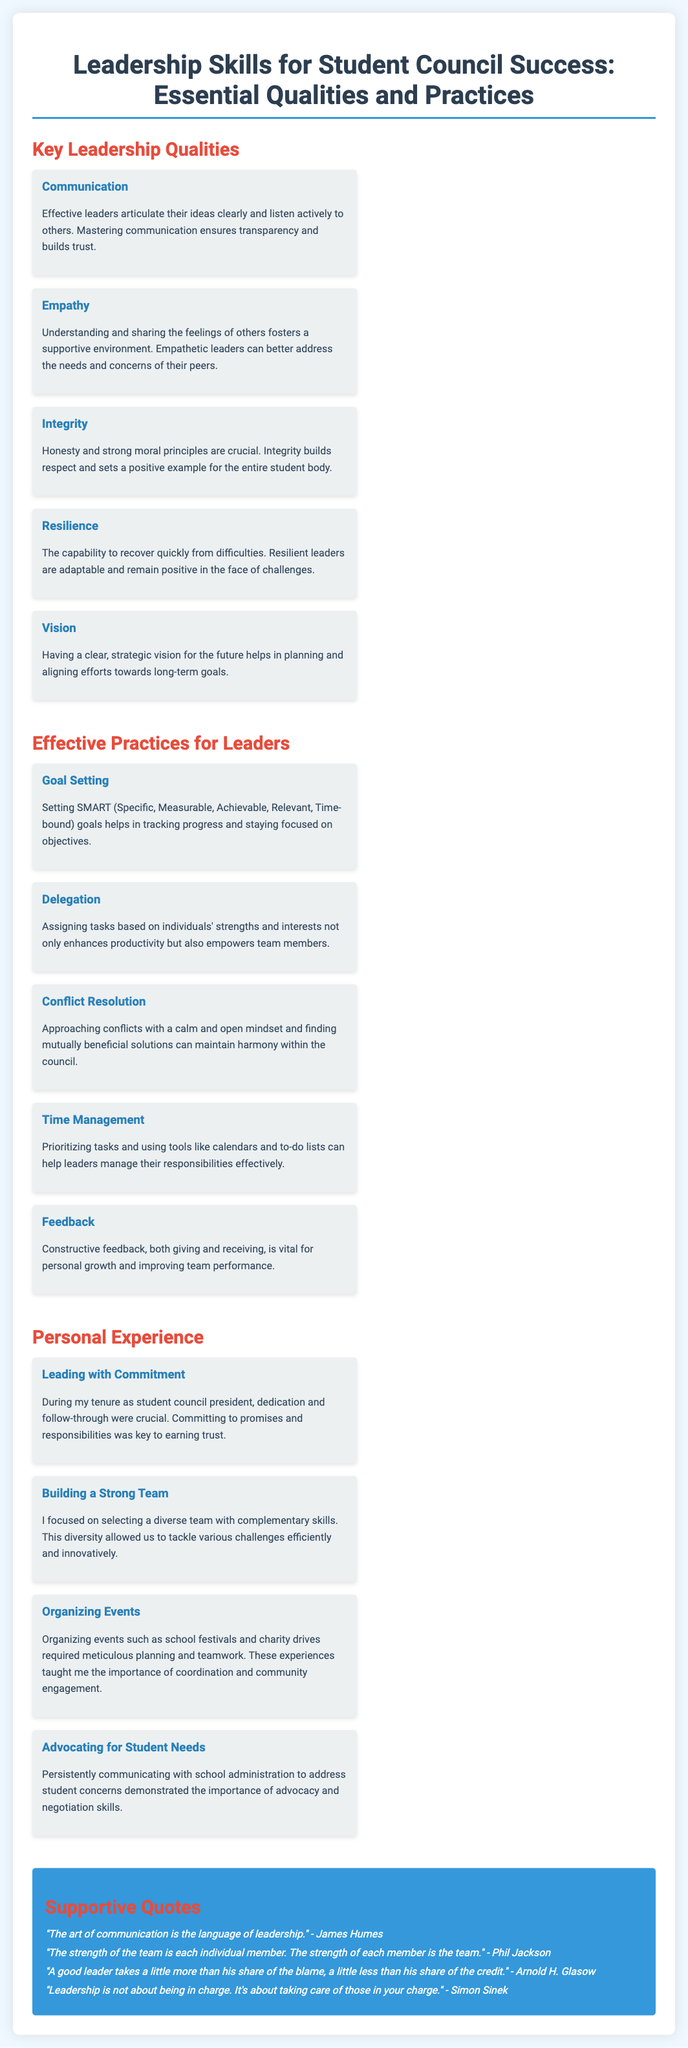What is the title of the poster? The title is clearly stated at the top of the document.
Answer: Leadership Skills for Student Council Success: Essential Qualities and Practices Who is quoted saying, "The strength of the team is each individual member"? This quote can be found in the quotes section of the document, attributed to Phil Jackson.
Answer: Phil Jackson How many key leadership qualities are listed? The document enumerates five key leadership qualities under the section.
Answer: Five What is the practice that involves assigning tasks? The document includes a section that describes delegation as a specific practice for leaders.
Answer: Delegation What quality is described as "the capability to recover quickly from difficulties"? This phrase directly refers to a specific leadership quality outlined in the poster.
Answer: Resilience Which quality emphasizes listening actively? This refers to a key leadership quality mentioned in the key leadership qualities section.
Answer: Communication What SMART stands for in goal setting? The acronym is explained in the practices section related to effective practices for leaders.
Answer: Specific, Measurable, Achievable, Relevant, Time-bound What does the section on personal experience emphasize about leadership? It highlights various aspects of personal experience during leadership, specifically referring to commitment.
Answer: Commitment 